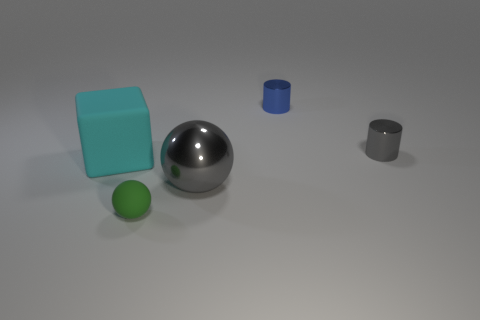What size is the ball that is made of the same material as the blue cylinder?
Offer a very short reply. Large. How many cubes are the same color as the tiny ball?
Provide a succinct answer. 0. Is the number of small matte spheres that are to the right of the big gray thing less than the number of tiny gray metallic cylinders that are right of the tiny green sphere?
Your response must be concise. Yes. There is a matte thing behind the green rubber ball; what size is it?
Make the answer very short. Large. What size is the other metal thing that is the same color as the large shiny thing?
Ensure brevity in your answer.  Small. Are there any small gray objects that have the same material as the large gray sphere?
Keep it short and to the point. Yes. Does the gray ball have the same material as the small green sphere?
Your answer should be compact. No. What is the color of the sphere that is the same size as the block?
Ensure brevity in your answer.  Gray. How many other things are the same shape as the cyan matte thing?
Provide a short and direct response. 0. Do the gray shiny sphere and the object to the left of the tiny ball have the same size?
Your response must be concise. Yes. 